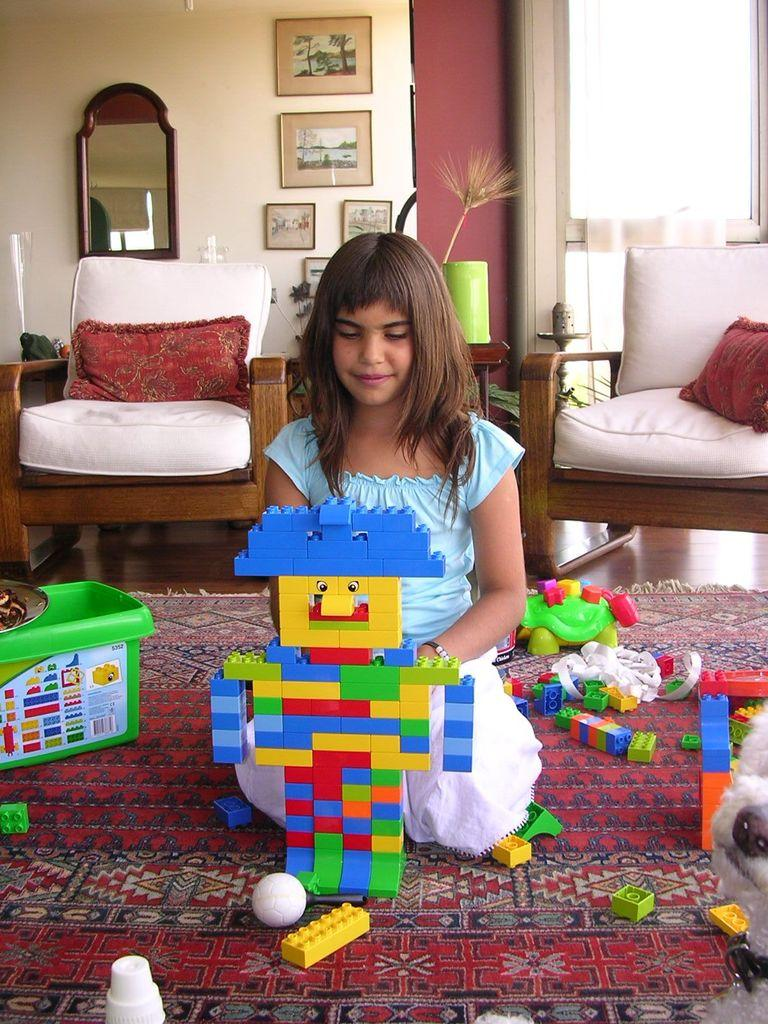What is the kid in the image doing? The kid is sitting on the floor and playing with a toy. Can you describe the background of the image? There is a white sofa and a mirror in the background. Where is the kid's aunt in the image? There is no mention of an aunt in the image, so we cannot determine her location. What type of tramp is visible in the image? There is no tramp present in the image. 